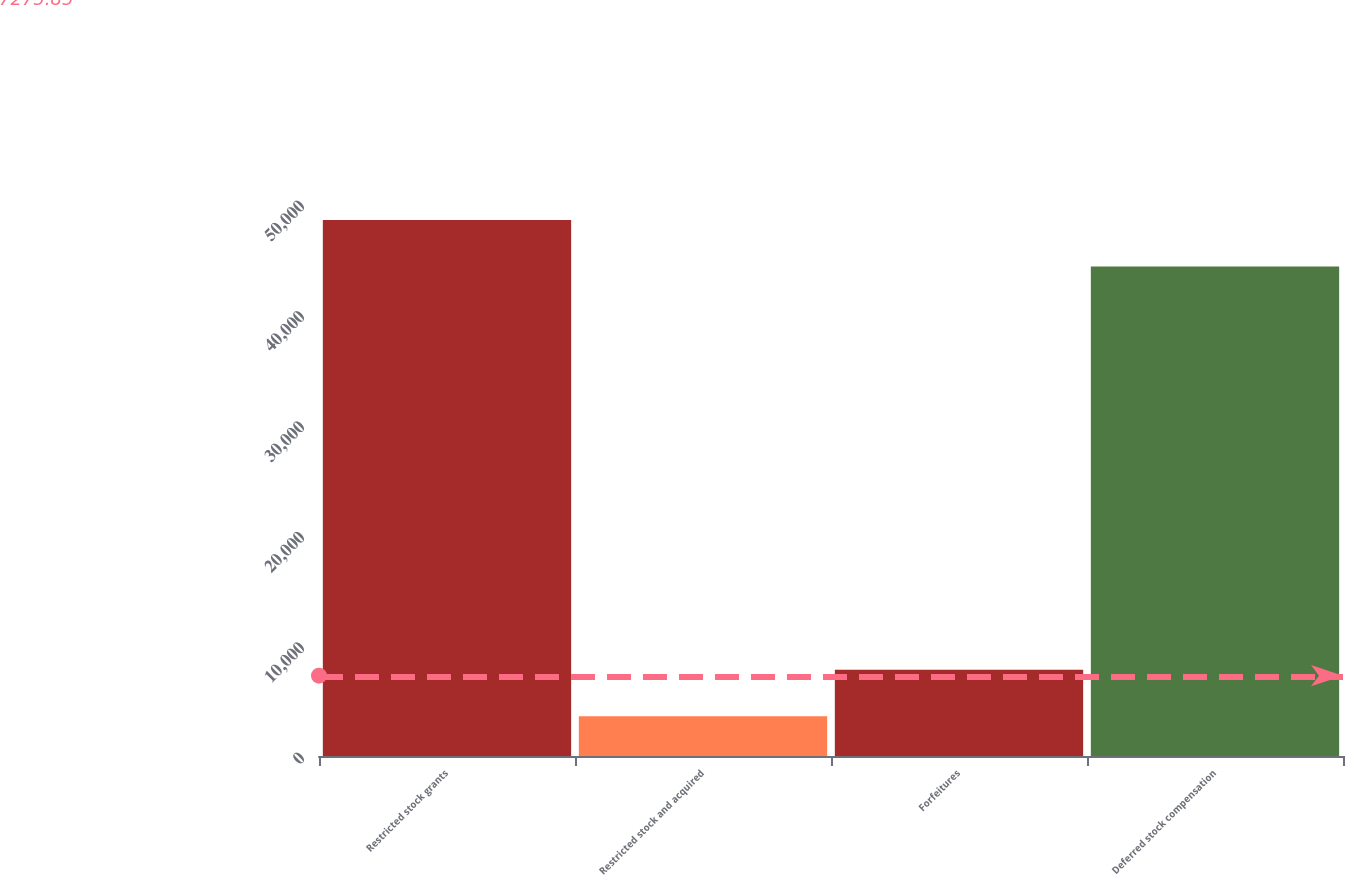<chart> <loc_0><loc_0><loc_500><loc_500><bar_chart><fcel>Restricted stock grants<fcel>Restricted stock and acquired<fcel>Forfeitures<fcel>Deferred stock compensation<nl><fcel>48547.2<fcel>3603<fcel>7803.2<fcel>44347<nl></chart> 